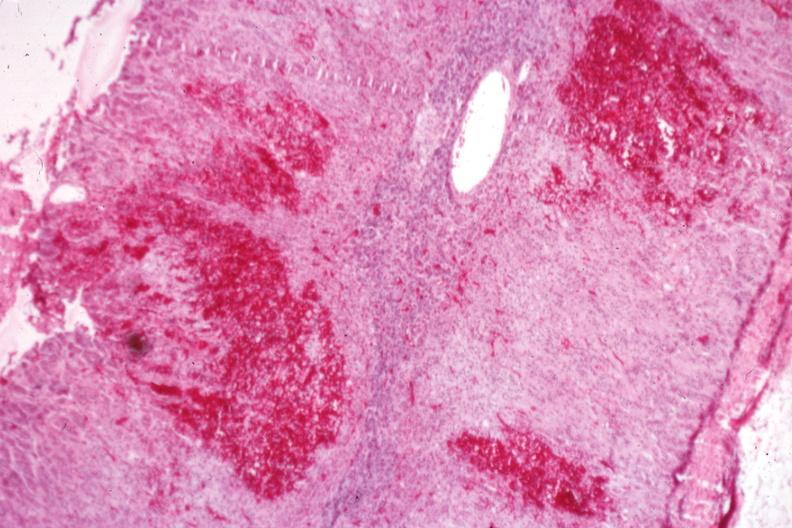s parathyroid present?
Answer the question using a single word or phrase. No 